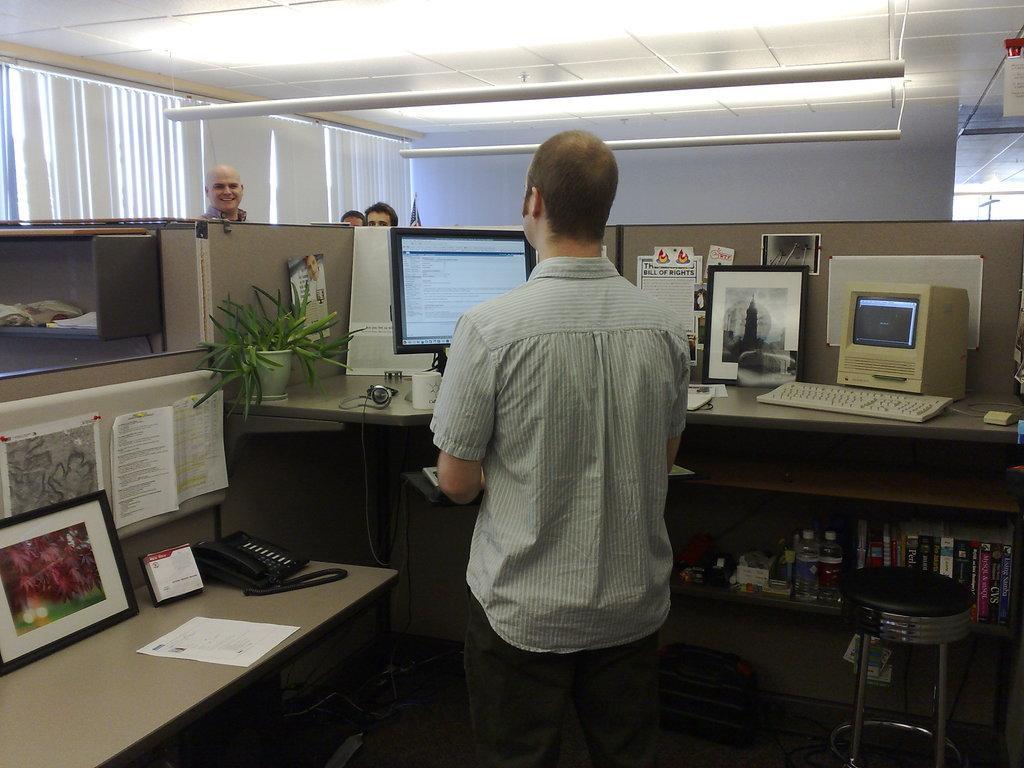Please provide a concise description of this image. The picture is taken inside a room where a person is standing in the middle and wearing a shirt and pant, in front of him there is a table on it there is a monitor and a flower pot and some papers on it and there is a keyboard and a photo and a telephone and some books and there is a shelf where there are books and water bottles and other things and a stool is present and in front of him there are three people standing and behind them there is a big window with curtains. 